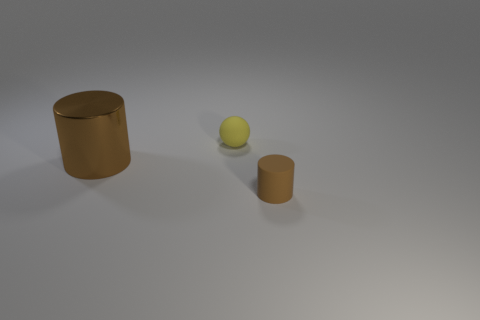What is the shape of the object that is right of the big brown shiny thing and on the left side of the tiny brown thing?
Provide a succinct answer. Sphere. There is a object that is the same material as the small cylinder; what is its size?
Your answer should be very brief. Small. Is the number of brown things less than the number of small yellow rubber spheres?
Ensure brevity in your answer.  No. There is a tiny object that is in front of the brown thing on the left side of the small rubber object that is right of the yellow sphere; what is it made of?
Provide a short and direct response. Rubber. Are the object left of the ball and the tiny thing behind the small matte cylinder made of the same material?
Offer a terse response. No. What is the size of the thing that is on the right side of the large brown cylinder and in front of the matte ball?
Give a very brief answer. Small. There is a brown thing that is the same size as the yellow thing; what material is it?
Your answer should be very brief. Rubber. What number of brown cylinders are behind the tiny rubber object that is behind the cylinder that is right of the yellow matte thing?
Provide a short and direct response. 0. Is the color of the cylinder to the left of the small brown matte thing the same as the small object in front of the matte sphere?
Keep it short and to the point. Yes. There is a thing that is both to the right of the large brown cylinder and on the left side of the brown rubber thing; what color is it?
Offer a terse response. Yellow. 